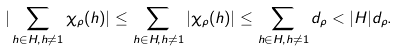<formula> <loc_0><loc_0><loc_500><loc_500>| \sum _ { h \in H , h \neq 1 } \chi _ { \rho } ( h ) | & \leq \sum _ { h \in H , h \neq 1 } | \chi _ { \rho } ( h ) | \leq \sum _ { h \in H , h \neq 1 } d _ { \rho } < | H | d _ { \rho } .</formula> 